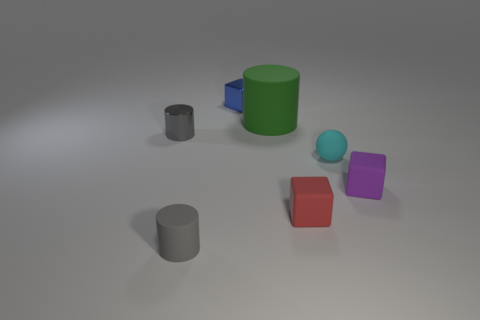Subtract all matte blocks. How many blocks are left? 1 Add 4 tiny cyan rubber balls. How many tiny cyan rubber balls exist? 5 Add 1 tiny red shiny objects. How many objects exist? 8 Subtract all blue cubes. How many cubes are left? 2 Subtract 1 purple blocks. How many objects are left? 6 Subtract all spheres. How many objects are left? 6 Subtract 2 blocks. How many blocks are left? 1 Subtract all blue cylinders. Subtract all red balls. How many cylinders are left? 3 Subtract all blue cylinders. How many gray cubes are left? 0 Subtract all rubber objects. Subtract all green cylinders. How many objects are left? 1 